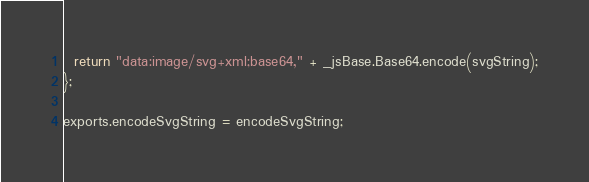<code> <loc_0><loc_0><loc_500><loc_500><_JavaScript_>  return "data:image/svg+xml;base64," + _jsBase.Base64.encode(svgString);
};

exports.encodeSvgString = encodeSvgString;</code> 